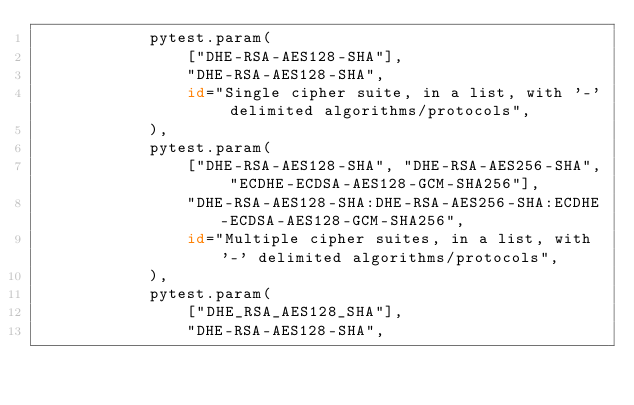<code> <loc_0><loc_0><loc_500><loc_500><_Python_>            pytest.param(
                ["DHE-RSA-AES128-SHA"],
                "DHE-RSA-AES128-SHA",
                id="Single cipher suite, in a list, with '-' delimited algorithms/protocols",
            ),
            pytest.param(
                ["DHE-RSA-AES128-SHA", "DHE-RSA-AES256-SHA", "ECDHE-ECDSA-AES128-GCM-SHA256"],
                "DHE-RSA-AES128-SHA:DHE-RSA-AES256-SHA:ECDHE-ECDSA-AES128-GCM-SHA256",
                id="Multiple cipher suites, in a list, with '-' delimited algorithms/protocols",
            ),
            pytest.param(
                ["DHE_RSA_AES128_SHA"],
                "DHE-RSA-AES128-SHA",</code> 